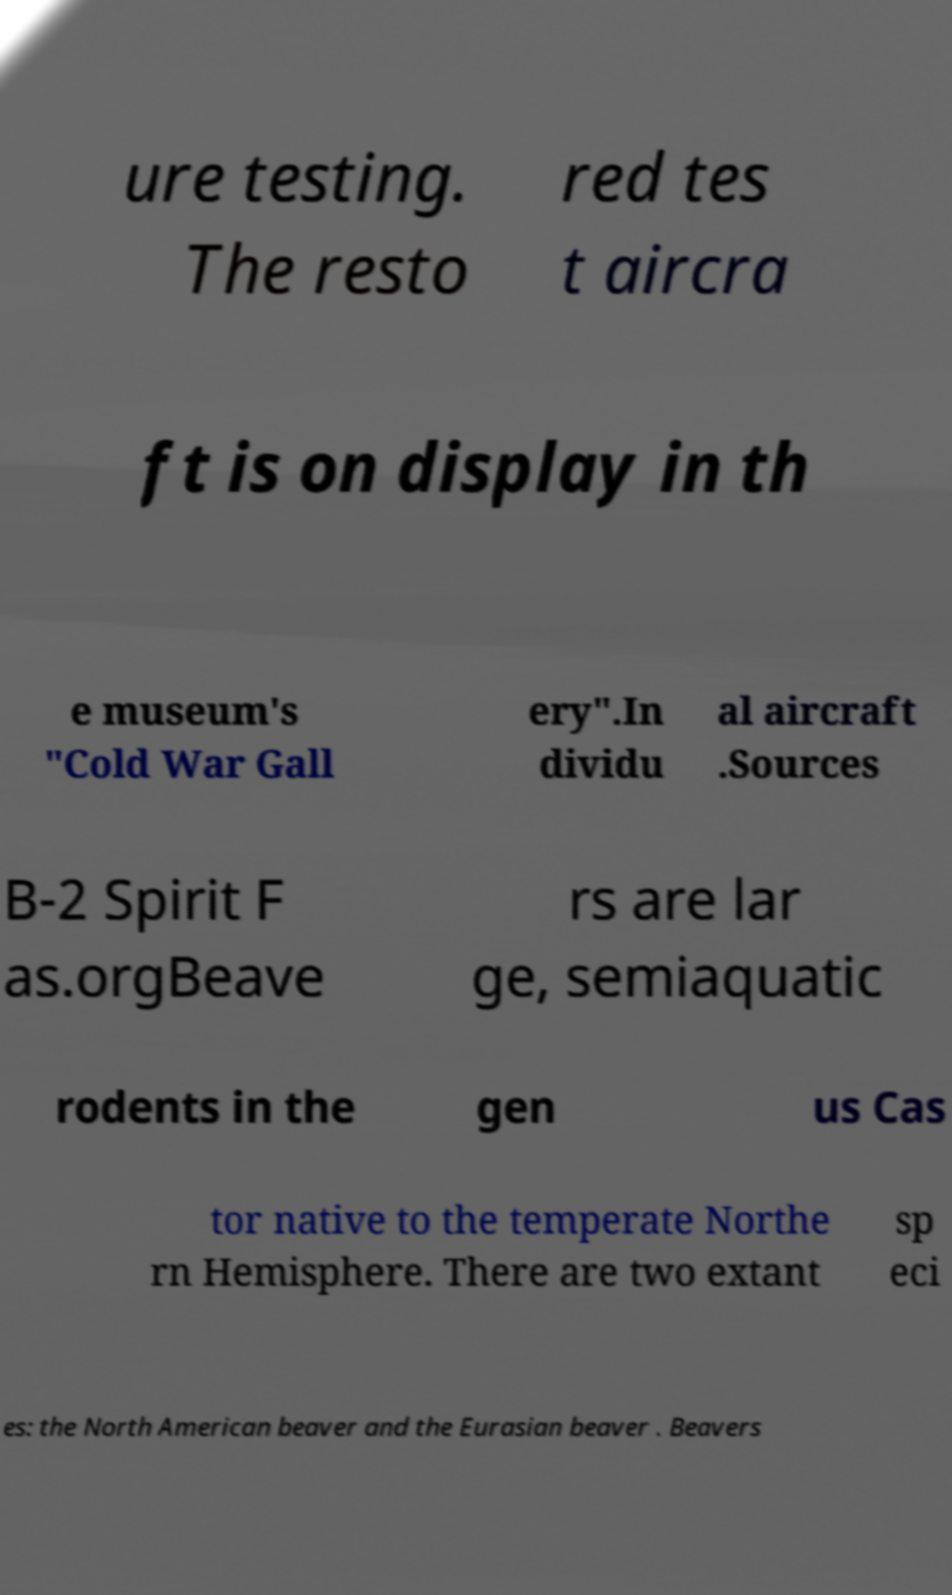For documentation purposes, I need the text within this image transcribed. Could you provide that? ure testing. The resto red tes t aircra ft is on display in th e museum's "Cold War Gall ery".In dividu al aircraft .Sources B-2 Spirit F as.orgBeave rs are lar ge, semiaquatic rodents in the gen us Cas tor native to the temperate Northe rn Hemisphere. There are two extant sp eci es: the North American beaver and the Eurasian beaver . Beavers 